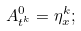<formula> <loc_0><loc_0><loc_500><loc_500>A _ { t ^ { k } } ^ { 0 } = \eta _ { x } ^ { k } ;</formula> 